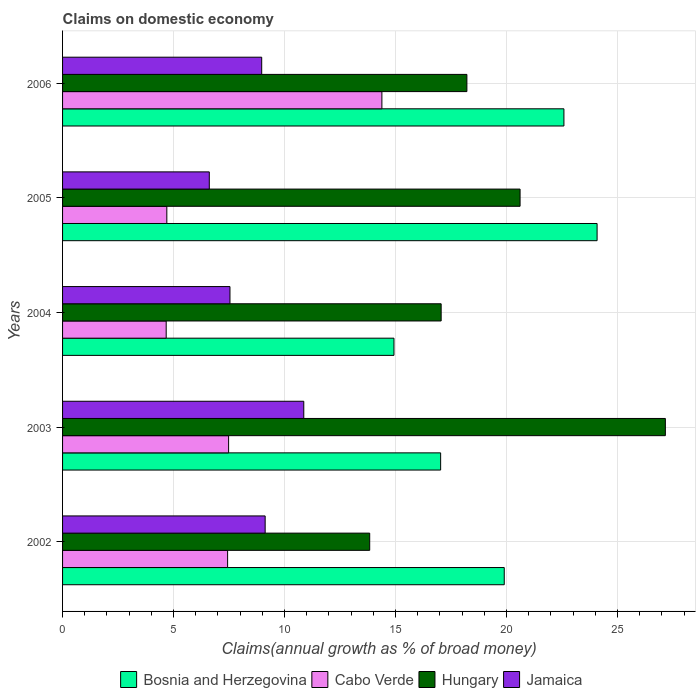How many different coloured bars are there?
Offer a very short reply. 4. How many groups of bars are there?
Offer a very short reply. 5. What is the percentage of broad money claimed on domestic economy in Hungary in 2005?
Provide a succinct answer. 20.61. Across all years, what is the maximum percentage of broad money claimed on domestic economy in Bosnia and Herzegovina?
Ensure brevity in your answer.  24.08. Across all years, what is the minimum percentage of broad money claimed on domestic economy in Cabo Verde?
Your answer should be compact. 4.67. What is the total percentage of broad money claimed on domestic economy in Bosnia and Herzegovina in the graph?
Provide a short and direct response. 98.54. What is the difference between the percentage of broad money claimed on domestic economy in Bosnia and Herzegovina in 2003 and that in 2005?
Keep it short and to the point. -7.05. What is the difference between the percentage of broad money claimed on domestic economy in Cabo Verde in 2004 and the percentage of broad money claimed on domestic economy in Hungary in 2005?
Give a very brief answer. -15.94. What is the average percentage of broad money claimed on domestic economy in Cabo Verde per year?
Your response must be concise. 7.73. In the year 2004, what is the difference between the percentage of broad money claimed on domestic economy in Jamaica and percentage of broad money claimed on domestic economy in Bosnia and Herzegovina?
Keep it short and to the point. -7.39. What is the ratio of the percentage of broad money claimed on domestic economy in Bosnia and Herzegovina in 2004 to that in 2006?
Offer a very short reply. 0.66. What is the difference between the highest and the second highest percentage of broad money claimed on domestic economy in Bosnia and Herzegovina?
Give a very brief answer. 1.49. What is the difference between the highest and the lowest percentage of broad money claimed on domestic economy in Jamaica?
Give a very brief answer. 4.26. In how many years, is the percentage of broad money claimed on domestic economy in Jamaica greater than the average percentage of broad money claimed on domestic economy in Jamaica taken over all years?
Offer a terse response. 3. Is the sum of the percentage of broad money claimed on domestic economy in Jamaica in 2004 and 2005 greater than the maximum percentage of broad money claimed on domestic economy in Bosnia and Herzegovina across all years?
Make the answer very short. No. Is it the case that in every year, the sum of the percentage of broad money claimed on domestic economy in Bosnia and Herzegovina and percentage of broad money claimed on domestic economy in Cabo Verde is greater than the sum of percentage of broad money claimed on domestic economy in Hungary and percentage of broad money claimed on domestic economy in Jamaica?
Ensure brevity in your answer.  No. What does the 2nd bar from the top in 2004 represents?
Your answer should be very brief. Hungary. What does the 3rd bar from the bottom in 2002 represents?
Provide a succinct answer. Hungary. Is it the case that in every year, the sum of the percentage of broad money claimed on domestic economy in Hungary and percentage of broad money claimed on domestic economy in Jamaica is greater than the percentage of broad money claimed on domestic economy in Bosnia and Herzegovina?
Offer a terse response. Yes. How many bars are there?
Your answer should be very brief. 20. Are all the bars in the graph horizontal?
Provide a succinct answer. Yes. What is the difference between two consecutive major ticks on the X-axis?
Provide a short and direct response. 5. Does the graph contain any zero values?
Make the answer very short. No. How are the legend labels stacked?
Offer a very short reply. Horizontal. What is the title of the graph?
Offer a terse response. Claims on domestic economy. What is the label or title of the X-axis?
Your answer should be compact. Claims(annual growth as % of broad money). What is the label or title of the Y-axis?
Make the answer very short. Years. What is the Claims(annual growth as % of broad money) of Bosnia and Herzegovina in 2002?
Offer a terse response. 19.9. What is the Claims(annual growth as % of broad money) of Cabo Verde in 2002?
Your answer should be very brief. 7.44. What is the Claims(annual growth as % of broad money) of Hungary in 2002?
Provide a succinct answer. 13.84. What is the Claims(annual growth as % of broad money) of Jamaica in 2002?
Provide a succinct answer. 9.13. What is the Claims(annual growth as % of broad money) in Bosnia and Herzegovina in 2003?
Keep it short and to the point. 17.04. What is the Claims(annual growth as % of broad money) in Cabo Verde in 2003?
Your answer should be compact. 7.48. What is the Claims(annual growth as % of broad money) of Hungary in 2003?
Provide a short and direct response. 27.16. What is the Claims(annual growth as % of broad money) in Jamaica in 2003?
Ensure brevity in your answer.  10.87. What is the Claims(annual growth as % of broad money) in Bosnia and Herzegovina in 2004?
Your answer should be very brief. 14.93. What is the Claims(annual growth as % of broad money) of Cabo Verde in 2004?
Your answer should be very brief. 4.67. What is the Claims(annual growth as % of broad money) of Hungary in 2004?
Ensure brevity in your answer.  17.06. What is the Claims(annual growth as % of broad money) of Jamaica in 2004?
Ensure brevity in your answer.  7.54. What is the Claims(annual growth as % of broad money) of Bosnia and Herzegovina in 2005?
Provide a short and direct response. 24.08. What is the Claims(annual growth as % of broad money) of Cabo Verde in 2005?
Your answer should be very brief. 4.7. What is the Claims(annual growth as % of broad money) of Hungary in 2005?
Provide a succinct answer. 20.61. What is the Claims(annual growth as % of broad money) in Jamaica in 2005?
Offer a very short reply. 6.61. What is the Claims(annual growth as % of broad money) in Bosnia and Herzegovina in 2006?
Provide a succinct answer. 22.59. What is the Claims(annual growth as % of broad money) in Cabo Verde in 2006?
Provide a succinct answer. 14.39. What is the Claims(annual growth as % of broad money) in Hungary in 2006?
Provide a short and direct response. 18.22. What is the Claims(annual growth as % of broad money) of Jamaica in 2006?
Provide a succinct answer. 8.97. Across all years, what is the maximum Claims(annual growth as % of broad money) of Bosnia and Herzegovina?
Your response must be concise. 24.08. Across all years, what is the maximum Claims(annual growth as % of broad money) of Cabo Verde?
Your answer should be compact. 14.39. Across all years, what is the maximum Claims(annual growth as % of broad money) in Hungary?
Offer a terse response. 27.16. Across all years, what is the maximum Claims(annual growth as % of broad money) in Jamaica?
Ensure brevity in your answer.  10.87. Across all years, what is the minimum Claims(annual growth as % of broad money) of Bosnia and Herzegovina?
Offer a very short reply. 14.93. Across all years, what is the minimum Claims(annual growth as % of broad money) in Cabo Verde?
Your answer should be compact. 4.67. Across all years, what is the minimum Claims(annual growth as % of broad money) in Hungary?
Make the answer very short. 13.84. Across all years, what is the minimum Claims(annual growth as % of broad money) in Jamaica?
Your answer should be compact. 6.61. What is the total Claims(annual growth as % of broad money) in Bosnia and Herzegovina in the graph?
Your response must be concise. 98.54. What is the total Claims(annual growth as % of broad money) of Cabo Verde in the graph?
Your answer should be very brief. 38.67. What is the total Claims(annual growth as % of broad money) in Hungary in the graph?
Your answer should be very brief. 96.89. What is the total Claims(annual growth as % of broad money) of Jamaica in the graph?
Offer a very short reply. 43.12. What is the difference between the Claims(annual growth as % of broad money) in Bosnia and Herzegovina in 2002 and that in 2003?
Your answer should be very brief. 2.87. What is the difference between the Claims(annual growth as % of broad money) of Cabo Verde in 2002 and that in 2003?
Provide a succinct answer. -0.05. What is the difference between the Claims(annual growth as % of broad money) in Hungary in 2002 and that in 2003?
Provide a succinct answer. -13.32. What is the difference between the Claims(annual growth as % of broad money) of Jamaica in 2002 and that in 2003?
Provide a succinct answer. -1.74. What is the difference between the Claims(annual growth as % of broad money) in Bosnia and Herzegovina in 2002 and that in 2004?
Provide a succinct answer. 4.97. What is the difference between the Claims(annual growth as % of broad money) in Cabo Verde in 2002 and that in 2004?
Provide a succinct answer. 2.77. What is the difference between the Claims(annual growth as % of broad money) in Hungary in 2002 and that in 2004?
Keep it short and to the point. -3.22. What is the difference between the Claims(annual growth as % of broad money) in Jamaica in 2002 and that in 2004?
Offer a very short reply. 1.59. What is the difference between the Claims(annual growth as % of broad money) in Bosnia and Herzegovina in 2002 and that in 2005?
Your response must be concise. -4.18. What is the difference between the Claims(annual growth as % of broad money) in Cabo Verde in 2002 and that in 2005?
Your response must be concise. 2.74. What is the difference between the Claims(annual growth as % of broad money) of Hungary in 2002 and that in 2005?
Keep it short and to the point. -6.78. What is the difference between the Claims(annual growth as % of broad money) of Jamaica in 2002 and that in 2005?
Ensure brevity in your answer.  2.52. What is the difference between the Claims(annual growth as % of broad money) in Bosnia and Herzegovina in 2002 and that in 2006?
Ensure brevity in your answer.  -2.69. What is the difference between the Claims(annual growth as % of broad money) in Cabo Verde in 2002 and that in 2006?
Give a very brief answer. -6.95. What is the difference between the Claims(annual growth as % of broad money) in Hungary in 2002 and that in 2006?
Your response must be concise. -4.38. What is the difference between the Claims(annual growth as % of broad money) in Jamaica in 2002 and that in 2006?
Keep it short and to the point. 0.16. What is the difference between the Claims(annual growth as % of broad money) in Bosnia and Herzegovina in 2003 and that in 2004?
Your response must be concise. 2.1. What is the difference between the Claims(annual growth as % of broad money) of Cabo Verde in 2003 and that in 2004?
Provide a short and direct response. 2.81. What is the difference between the Claims(annual growth as % of broad money) in Hungary in 2003 and that in 2004?
Make the answer very short. 10.1. What is the difference between the Claims(annual growth as % of broad money) in Jamaica in 2003 and that in 2004?
Make the answer very short. 3.33. What is the difference between the Claims(annual growth as % of broad money) in Bosnia and Herzegovina in 2003 and that in 2005?
Ensure brevity in your answer.  -7.05. What is the difference between the Claims(annual growth as % of broad money) in Cabo Verde in 2003 and that in 2005?
Provide a succinct answer. 2.78. What is the difference between the Claims(annual growth as % of broad money) of Hungary in 2003 and that in 2005?
Ensure brevity in your answer.  6.55. What is the difference between the Claims(annual growth as % of broad money) in Jamaica in 2003 and that in 2005?
Your answer should be very brief. 4.26. What is the difference between the Claims(annual growth as % of broad money) of Bosnia and Herzegovina in 2003 and that in 2006?
Keep it short and to the point. -5.55. What is the difference between the Claims(annual growth as % of broad money) of Cabo Verde in 2003 and that in 2006?
Ensure brevity in your answer.  -6.91. What is the difference between the Claims(annual growth as % of broad money) in Hungary in 2003 and that in 2006?
Your response must be concise. 8.94. What is the difference between the Claims(annual growth as % of broad money) of Jamaica in 2003 and that in 2006?
Make the answer very short. 1.9. What is the difference between the Claims(annual growth as % of broad money) of Bosnia and Herzegovina in 2004 and that in 2005?
Give a very brief answer. -9.15. What is the difference between the Claims(annual growth as % of broad money) of Cabo Verde in 2004 and that in 2005?
Give a very brief answer. -0.03. What is the difference between the Claims(annual growth as % of broad money) in Hungary in 2004 and that in 2005?
Offer a terse response. -3.56. What is the difference between the Claims(annual growth as % of broad money) of Jamaica in 2004 and that in 2005?
Your answer should be compact. 0.93. What is the difference between the Claims(annual growth as % of broad money) in Bosnia and Herzegovina in 2004 and that in 2006?
Provide a succinct answer. -7.66. What is the difference between the Claims(annual growth as % of broad money) of Cabo Verde in 2004 and that in 2006?
Provide a short and direct response. -9.72. What is the difference between the Claims(annual growth as % of broad money) in Hungary in 2004 and that in 2006?
Keep it short and to the point. -1.16. What is the difference between the Claims(annual growth as % of broad money) of Jamaica in 2004 and that in 2006?
Keep it short and to the point. -1.43. What is the difference between the Claims(annual growth as % of broad money) in Bosnia and Herzegovina in 2005 and that in 2006?
Offer a terse response. 1.49. What is the difference between the Claims(annual growth as % of broad money) of Cabo Verde in 2005 and that in 2006?
Ensure brevity in your answer.  -9.69. What is the difference between the Claims(annual growth as % of broad money) in Hungary in 2005 and that in 2006?
Provide a succinct answer. 2.4. What is the difference between the Claims(annual growth as % of broad money) in Jamaica in 2005 and that in 2006?
Offer a very short reply. -2.36. What is the difference between the Claims(annual growth as % of broad money) in Bosnia and Herzegovina in 2002 and the Claims(annual growth as % of broad money) in Cabo Verde in 2003?
Your response must be concise. 12.42. What is the difference between the Claims(annual growth as % of broad money) in Bosnia and Herzegovina in 2002 and the Claims(annual growth as % of broad money) in Hungary in 2003?
Provide a short and direct response. -7.26. What is the difference between the Claims(annual growth as % of broad money) of Bosnia and Herzegovina in 2002 and the Claims(annual growth as % of broad money) of Jamaica in 2003?
Offer a very short reply. 9.03. What is the difference between the Claims(annual growth as % of broad money) of Cabo Verde in 2002 and the Claims(annual growth as % of broad money) of Hungary in 2003?
Make the answer very short. -19.72. What is the difference between the Claims(annual growth as % of broad money) of Cabo Verde in 2002 and the Claims(annual growth as % of broad money) of Jamaica in 2003?
Provide a succinct answer. -3.43. What is the difference between the Claims(annual growth as % of broad money) of Hungary in 2002 and the Claims(annual growth as % of broad money) of Jamaica in 2003?
Give a very brief answer. 2.97. What is the difference between the Claims(annual growth as % of broad money) in Bosnia and Herzegovina in 2002 and the Claims(annual growth as % of broad money) in Cabo Verde in 2004?
Ensure brevity in your answer.  15.23. What is the difference between the Claims(annual growth as % of broad money) of Bosnia and Herzegovina in 2002 and the Claims(annual growth as % of broad money) of Hungary in 2004?
Your response must be concise. 2.84. What is the difference between the Claims(annual growth as % of broad money) of Bosnia and Herzegovina in 2002 and the Claims(annual growth as % of broad money) of Jamaica in 2004?
Your answer should be compact. 12.36. What is the difference between the Claims(annual growth as % of broad money) in Cabo Verde in 2002 and the Claims(annual growth as % of broad money) in Hungary in 2004?
Provide a succinct answer. -9.62. What is the difference between the Claims(annual growth as % of broad money) of Cabo Verde in 2002 and the Claims(annual growth as % of broad money) of Jamaica in 2004?
Your answer should be very brief. -0.11. What is the difference between the Claims(annual growth as % of broad money) of Hungary in 2002 and the Claims(annual growth as % of broad money) of Jamaica in 2004?
Keep it short and to the point. 6.3. What is the difference between the Claims(annual growth as % of broad money) of Bosnia and Herzegovina in 2002 and the Claims(annual growth as % of broad money) of Cabo Verde in 2005?
Make the answer very short. 15.2. What is the difference between the Claims(annual growth as % of broad money) of Bosnia and Herzegovina in 2002 and the Claims(annual growth as % of broad money) of Hungary in 2005?
Offer a very short reply. -0.71. What is the difference between the Claims(annual growth as % of broad money) of Bosnia and Herzegovina in 2002 and the Claims(annual growth as % of broad money) of Jamaica in 2005?
Provide a short and direct response. 13.29. What is the difference between the Claims(annual growth as % of broad money) of Cabo Verde in 2002 and the Claims(annual growth as % of broad money) of Hungary in 2005?
Give a very brief answer. -13.18. What is the difference between the Claims(annual growth as % of broad money) of Cabo Verde in 2002 and the Claims(annual growth as % of broad money) of Jamaica in 2005?
Ensure brevity in your answer.  0.82. What is the difference between the Claims(annual growth as % of broad money) of Hungary in 2002 and the Claims(annual growth as % of broad money) of Jamaica in 2005?
Offer a very short reply. 7.23. What is the difference between the Claims(annual growth as % of broad money) of Bosnia and Herzegovina in 2002 and the Claims(annual growth as % of broad money) of Cabo Verde in 2006?
Ensure brevity in your answer.  5.51. What is the difference between the Claims(annual growth as % of broad money) in Bosnia and Herzegovina in 2002 and the Claims(annual growth as % of broad money) in Hungary in 2006?
Your answer should be compact. 1.68. What is the difference between the Claims(annual growth as % of broad money) in Bosnia and Herzegovina in 2002 and the Claims(annual growth as % of broad money) in Jamaica in 2006?
Give a very brief answer. 10.93. What is the difference between the Claims(annual growth as % of broad money) in Cabo Verde in 2002 and the Claims(annual growth as % of broad money) in Hungary in 2006?
Keep it short and to the point. -10.78. What is the difference between the Claims(annual growth as % of broad money) of Cabo Verde in 2002 and the Claims(annual growth as % of broad money) of Jamaica in 2006?
Give a very brief answer. -1.54. What is the difference between the Claims(annual growth as % of broad money) of Hungary in 2002 and the Claims(annual growth as % of broad money) of Jamaica in 2006?
Offer a terse response. 4.87. What is the difference between the Claims(annual growth as % of broad money) of Bosnia and Herzegovina in 2003 and the Claims(annual growth as % of broad money) of Cabo Verde in 2004?
Keep it short and to the point. 12.37. What is the difference between the Claims(annual growth as % of broad money) of Bosnia and Herzegovina in 2003 and the Claims(annual growth as % of broad money) of Hungary in 2004?
Your answer should be very brief. -0.02. What is the difference between the Claims(annual growth as % of broad money) of Bosnia and Herzegovina in 2003 and the Claims(annual growth as % of broad money) of Jamaica in 2004?
Offer a terse response. 9.49. What is the difference between the Claims(annual growth as % of broad money) in Cabo Verde in 2003 and the Claims(annual growth as % of broad money) in Hungary in 2004?
Offer a very short reply. -9.58. What is the difference between the Claims(annual growth as % of broad money) of Cabo Verde in 2003 and the Claims(annual growth as % of broad money) of Jamaica in 2004?
Offer a very short reply. -0.06. What is the difference between the Claims(annual growth as % of broad money) of Hungary in 2003 and the Claims(annual growth as % of broad money) of Jamaica in 2004?
Keep it short and to the point. 19.62. What is the difference between the Claims(annual growth as % of broad money) of Bosnia and Herzegovina in 2003 and the Claims(annual growth as % of broad money) of Cabo Verde in 2005?
Provide a succinct answer. 12.34. What is the difference between the Claims(annual growth as % of broad money) in Bosnia and Herzegovina in 2003 and the Claims(annual growth as % of broad money) in Hungary in 2005?
Your response must be concise. -3.58. What is the difference between the Claims(annual growth as % of broad money) in Bosnia and Herzegovina in 2003 and the Claims(annual growth as % of broad money) in Jamaica in 2005?
Make the answer very short. 10.42. What is the difference between the Claims(annual growth as % of broad money) in Cabo Verde in 2003 and the Claims(annual growth as % of broad money) in Hungary in 2005?
Offer a very short reply. -13.13. What is the difference between the Claims(annual growth as % of broad money) in Cabo Verde in 2003 and the Claims(annual growth as % of broad money) in Jamaica in 2005?
Offer a very short reply. 0.87. What is the difference between the Claims(annual growth as % of broad money) in Hungary in 2003 and the Claims(annual growth as % of broad money) in Jamaica in 2005?
Keep it short and to the point. 20.55. What is the difference between the Claims(annual growth as % of broad money) in Bosnia and Herzegovina in 2003 and the Claims(annual growth as % of broad money) in Cabo Verde in 2006?
Provide a succinct answer. 2.65. What is the difference between the Claims(annual growth as % of broad money) of Bosnia and Herzegovina in 2003 and the Claims(annual growth as % of broad money) of Hungary in 2006?
Offer a terse response. -1.18. What is the difference between the Claims(annual growth as % of broad money) in Bosnia and Herzegovina in 2003 and the Claims(annual growth as % of broad money) in Jamaica in 2006?
Provide a short and direct response. 8.06. What is the difference between the Claims(annual growth as % of broad money) of Cabo Verde in 2003 and the Claims(annual growth as % of broad money) of Hungary in 2006?
Offer a very short reply. -10.74. What is the difference between the Claims(annual growth as % of broad money) of Cabo Verde in 2003 and the Claims(annual growth as % of broad money) of Jamaica in 2006?
Your answer should be compact. -1.49. What is the difference between the Claims(annual growth as % of broad money) in Hungary in 2003 and the Claims(annual growth as % of broad money) in Jamaica in 2006?
Your answer should be very brief. 18.19. What is the difference between the Claims(annual growth as % of broad money) in Bosnia and Herzegovina in 2004 and the Claims(annual growth as % of broad money) in Cabo Verde in 2005?
Provide a short and direct response. 10.23. What is the difference between the Claims(annual growth as % of broad money) in Bosnia and Herzegovina in 2004 and the Claims(annual growth as % of broad money) in Hungary in 2005?
Offer a terse response. -5.68. What is the difference between the Claims(annual growth as % of broad money) in Bosnia and Herzegovina in 2004 and the Claims(annual growth as % of broad money) in Jamaica in 2005?
Keep it short and to the point. 8.32. What is the difference between the Claims(annual growth as % of broad money) in Cabo Verde in 2004 and the Claims(annual growth as % of broad money) in Hungary in 2005?
Your answer should be compact. -15.94. What is the difference between the Claims(annual growth as % of broad money) of Cabo Verde in 2004 and the Claims(annual growth as % of broad money) of Jamaica in 2005?
Your response must be concise. -1.94. What is the difference between the Claims(annual growth as % of broad money) in Hungary in 2004 and the Claims(annual growth as % of broad money) in Jamaica in 2005?
Your answer should be very brief. 10.45. What is the difference between the Claims(annual growth as % of broad money) in Bosnia and Herzegovina in 2004 and the Claims(annual growth as % of broad money) in Cabo Verde in 2006?
Provide a succinct answer. 0.54. What is the difference between the Claims(annual growth as % of broad money) of Bosnia and Herzegovina in 2004 and the Claims(annual growth as % of broad money) of Hungary in 2006?
Make the answer very short. -3.29. What is the difference between the Claims(annual growth as % of broad money) in Bosnia and Herzegovina in 2004 and the Claims(annual growth as % of broad money) in Jamaica in 2006?
Give a very brief answer. 5.96. What is the difference between the Claims(annual growth as % of broad money) in Cabo Verde in 2004 and the Claims(annual growth as % of broad money) in Hungary in 2006?
Offer a terse response. -13.55. What is the difference between the Claims(annual growth as % of broad money) in Cabo Verde in 2004 and the Claims(annual growth as % of broad money) in Jamaica in 2006?
Your answer should be compact. -4.3. What is the difference between the Claims(annual growth as % of broad money) in Hungary in 2004 and the Claims(annual growth as % of broad money) in Jamaica in 2006?
Ensure brevity in your answer.  8.09. What is the difference between the Claims(annual growth as % of broad money) of Bosnia and Herzegovina in 2005 and the Claims(annual growth as % of broad money) of Cabo Verde in 2006?
Keep it short and to the point. 9.7. What is the difference between the Claims(annual growth as % of broad money) in Bosnia and Herzegovina in 2005 and the Claims(annual growth as % of broad money) in Hungary in 2006?
Keep it short and to the point. 5.87. What is the difference between the Claims(annual growth as % of broad money) of Bosnia and Herzegovina in 2005 and the Claims(annual growth as % of broad money) of Jamaica in 2006?
Make the answer very short. 15.11. What is the difference between the Claims(annual growth as % of broad money) in Cabo Verde in 2005 and the Claims(annual growth as % of broad money) in Hungary in 2006?
Provide a short and direct response. -13.52. What is the difference between the Claims(annual growth as % of broad money) of Cabo Verde in 2005 and the Claims(annual growth as % of broad money) of Jamaica in 2006?
Give a very brief answer. -4.28. What is the difference between the Claims(annual growth as % of broad money) of Hungary in 2005 and the Claims(annual growth as % of broad money) of Jamaica in 2006?
Make the answer very short. 11.64. What is the average Claims(annual growth as % of broad money) in Bosnia and Herzegovina per year?
Your answer should be very brief. 19.71. What is the average Claims(annual growth as % of broad money) of Cabo Verde per year?
Give a very brief answer. 7.73. What is the average Claims(annual growth as % of broad money) of Hungary per year?
Offer a very short reply. 19.38. What is the average Claims(annual growth as % of broad money) in Jamaica per year?
Your response must be concise. 8.62. In the year 2002, what is the difference between the Claims(annual growth as % of broad money) of Bosnia and Herzegovina and Claims(annual growth as % of broad money) of Cabo Verde?
Your answer should be compact. 12.46. In the year 2002, what is the difference between the Claims(annual growth as % of broad money) of Bosnia and Herzegovina and Claims(annual growth as % of broad money) of Hungary?
Offer a terse response. 6.06. In the year 2002, what is the difference between the Claims(annual growth as % of broad money) of Bosnia and Herzegovina and Claims(annual growth as % of broad money) of Jamaica?
Provide a succinct answer. 10.77. In the year 2002, what is the difference between the Claims(annual growth as % of broad money) of Cabo Verde and Claims(annual growth as % of broad money) of Hungary?
Make the answer very short. -6.4. In the year 2002, what is the difference between the Claims(annual growth as % of broad money) in Cabo Verde and Claims(annual growth as % of broad money) in Jamaica?
Provide a succinct answer. -1.69. In the year 2002, what is the difference between the Claims(annual growth as % of broad money) in Hungary and Claims(annual growth as % of broad money) in Jamaica?
Provide a short and direct response. 4.71. In the year 2003, what is the difference between the Claims(annual growth as % of broad money) in Bosnia and Herzegovina and Claims(annual growth as % of broad money) in Cabo Verde?
Your answer should be very brief. 9.55. In the year 2003, what is the difference between the Claims(annual growth as % of broad money) in Bosnia and Herzegovina and Claims(annual growth as % of broad money) in Hungary?
Provide a short and direct response. -10.12. In the year 2003, what is the difference between the Claims(annual growth as % of broad money) of Bosnia and Herzegovina and Claims(annual growth as % of broad money) of Jamaica?
Provide a succinct answer. 6.17. In the year 2003, what is the difference between the Claims(annual growth as % of broad money) in Cabo Verde and Claims(annual growth as % of broad money) in Hungary?
Your answer should be compact. -19.68. In the year 2003, what is the difference between the Claims(annual growth as % of broad money) in Cabo Verde and Claims(annual growth as % of broad money) in Jamaica?
Provide a short and direct response. -3.39. In the year 2003, what is the difference between the Claims(annual growth as % of broad money) in Hungary and Claims(annual growth as % of broad money) in Jamaica?
Offer a very short reply. 16.29. In the year 2004, what is the difference between the Claims(annual growth as % of broad money) of Bosnia and Herzegovina and Claims(annual growth as % of broad money) of Cabo Verde?
Keep it short and to the point. 10.26. In the year 2004, what is the difference between the Claims(annual growth as % of broad money) of Bosnia and Herzegovina and Claims(annual growth as % of broad money) of Hungary?
Offer a terse response. -2.13. In the year 2004, what is the difference between the Claims(annual growth as % of broad money) in Bosnia and Herzegovina and Claims(annual growth as % of broad money) in Jamaica?
Offer a very short reply. 7.39. In the year 2004, what is the difference between the Claims(annual growth as % of broad money) in Cabo Verde and Claims(annual growth as % of broad money) in Hungary?
Keep it short and to the point. -12.39. In the year 2004, what is the difference between the Claims(annual growth as % of broad money) of Cabo Verde and Claims(annual growth as % of broad money) of Jamaica?
Your response must be concise. -2.87. In the year 2004, what is the difference between the Claims(annual growth as % of broad money) in Hungary and Claims(annual growth as % of broad money) in Jamaica?
Ensure brevity in your answer.  9.52. In the year 2005, what is the difference between the Claims(annual growth as % of broad money) in Bosnia and Herzegovina and Claims(annual growth as % of broad money) in Cabo Verde?
Ensure brevity in your answer.  19.39. In the year 2005, what is the difference between the Claims(annual growth as % of broad money) in Bosnia and Herzegovina and Claims(annual growth as % of broad money) in Hungary?
Give a very brief answer. 3.47. In the year 2005, what is the difference between the Claims(annual growth as % of broad money) of Bosnia and Herzegovina and Claims(annual growth as % of broad money) of Jamaica?
Ensure brevity in your answer.  17.47. In the year 2005, what is the difference between the Claims(annual growth as % of broad money) of Cabo Verde and Claims(annual growth as % of broad money) of Hungary?
Ensure brevity in your answer.  -15.92. In the year 2005, what is the difference between the Claims(annual growth as % of broad money) of Cabo Verde and Claims(annual growth as % of broad money) of Jamaica?
Provide a succinct answer. -1.91. In the year 2005, what is the difference between the Claims(annual growth as % of broad money) in Hungary and Claims(annual growth as % of broad money) in Jamaica?
Offer a very short reply. 14. In the year 2006, what is the difference between the Claims(annual growth as % of broad money) of Bosnia and Herzegovina and Claims(annual growth as % of broad money) of Cabo Verde?
Offer a very short reply. 8.2. In the year 2006, what is the difference between the Claims(annual growth as % of broad money) in Bosnia and Herzegovina and Claims(annual growth as % of broad money) in Hungary?
Give a very brief answer. 4.37. In the year 2006, what is the difference between the Claims(annual growth as % of broad money) of Bosnia and Herzegovina and Claims(annual growth as % of broad money) of Jamaica?
Provide a succinct answer. 13.62. In the year 2006, what is the difference between the Claims(annual growth as % of broad money) of Cabo Verde and Claims(annual growth as % of broad money) of Hungary?
Your answer should be very brief. -3.83. In the year 2006, what is the difference between the Claims(annual growth as % of broad money) in Cabo Verde and Claims(annual growth as % of broad money) in Jamaica?
Give a very brief answer. 5.41. In the year 2006, what is the difference between the Claims(annual growth as % of broad money) of Hungary and Claims(annual growth as % of broad money) of Jamaica?
Your response must be concise. 9.24. What is the ratio of the Claims(annual growth as % of broad money) of Bosnia and Herzegovina in 2002 to that in 2003?
Your answer should be compact. 1.17. What is the ratio of the Claims(annual growth as % of broad money) of Cabo Verde in 2002 to that in 2003?
Ensure brevity in your answer.  0.99. What is the ratio of the Claims(annual growth as % of broad money) of Hungary in 2002 to that in 2003?
Give a very brief answer. 0.51. What is the ratio of the Claims(annual growth as % of broad money) in Jamaica in 2002 to that in 2003?
Offer a very short reply. 0.84. What is the ratio of the Claims(annual growth as % of broad money) in Bosnia and Herzegovina in 2002 to that in 2004?
Make the answer very short. 1.33. What is the ratio of the Claims(annual growth as % of broad money) of Cabo Verde in 2002 to that in 2004?
Your response must be concise. 1.59. What is the ratio of the Claims(annual growth as % of broad money) in Hungary in 2002 to that in 2004?
Your answer should be compact. 0.81. What is the ratio of the Claims(annual growth as % of broad money) of Jamaica in 2002 to that in 2004?
Your response must be concise. 1.21. What is the ratio of the Claims(annual growth as % of broad money) in Bosnia and Herzegovina in 2002 to that in 2005?
Keep it short and to the point. 0.83. What is the ratio of the Claims(annual growth as % of broad money) of Cabo Verde in 2002 to that in 2005?
Your response must be concise. 1.58. What is the ratio of the Claims(annual growth as % of broad money) of Hungary in 2002 to that in 2005?
Give a very brief answer. 0.67. What is the ratio of the Claims(annual growth as % of broad money) in Jamaica in 2002 to that in 2005?
Make the answer very short. 1.38. What is the ratio of the Claims(annual growth as % of broad money) in Bosnia and Herzegovina in 2002 to that in 2006?
Your response must be concise. 0.88. What is the ratio of the Claims(annual growth as % of broad money) of Cabo Verde in 2002 to that in 2006?
Offer a terse response. 0.52. What is the ratio of the Claims(annual growth as % of broad money) in Hungary in 2002 to that in 2006?
Your answer should be very brief. 0.76. What is the ratio of the Claims(annual growth as % of broad money) in Jamaica in 2002 to that in 2006?
Ensure brevity in your answer.  1.02. What is the ratio of the Claims(annual growth as % of broad money) in Bosnia and Herzegovina in 2003 to that in 2004?
Your answer should be compact. 1.14. What is the ratio of the Claims(annual growth as % of broad money) in Cabo Verde in 2003 to that in 2004?
Provide a short and direct response. 1.6. What is the ratio of the Claims(annual growth as % of broad money) in Hungary in 2003 to that in 2004?
Your response must be concise. 1.59. What is the ratio of the Claims(annual growth as % of broad money) of Jamaica in 2003 to that in 2004?
Your answer should be very brief. 1.44. What is the ratio of the Claims(annual growth as % of broad money) in Bosnia and Herzegovina in 2003 to that in 2005?
Offer a very short reply. 0.71. What is the ratio of the Claims(annual growth as % of broad money) of Cabo Verde in 2003 to that in 2005?
Your response must be concise. 1.59. What is the ratio of the Claims(annual growth as % of broad money) of Hungary in 2003 to that in 2005?
Ensure brevity in your answer.  1.32. What is the ratio of the Claims(annual growth as % of broad money) in Jamaica in 2003 to that in 2005?
Provide a succinct answer. 1.64. What is the ratio of the Claims(annual growth as % of broad money) of Bosnia and Herzegovina in 2003 to that in 2006?
Provide a succinct answer. 0.75. What is the ratio of the Claims(annual growth as % of broad money) of Cabo Verde in 2003 to that in 2006?
Your answer should be very brief. 0.52. What is the ratio of the Claims(annual growth as % of broad money) in Hungary in 2003 to that in 2006?
Your answer should be very brief. 1.49. What is the ratio of the Claims(annual growth as % of broad money) of Jamaica in 2003 to that in 2006?
Offer a terse response. 1.21. What is the ratio of the Claims(annual growth as % of broad money) in Bosnia and Herzegovina in 2004 to that in 2005?
Offer a terse response. 0.62. What is the ratio of the Claims(annual growth as % of broad money) of Cabo Verde in 2004 to that in 2005?
Ensure brevity in your answer.  0.99. What is the ratio of the Claims(annual growth as % of broad money) in Hungary in 2004 to that in 2005?
Your answer should be compact. 0.83. What is the ratio of the Claims(annual growth as % of broad money) in Jamaica in 2004 to that in 2005?
Ensure brevity in your answer.  1.14. What is the ratio of the Claims(annual growth as % of broad money) in Bosnia and Herzegovina in 2004 to that in 2006?
Make the answer very short. 0.66. What is the ratio of the Claims(annual growth as % of broad money) in Cabo Verde in 2004 to that in 2006?
Make the answer very short. 0.32. What is the ratio of the Claims(annual growth as % of broad money) of Hungary in 2004 to that in 2006?
Offer a very short reply. 0.94. What is the ratio of the Claims(annual growth as % of broad money) of Jamaica in 2004 to that in 2006?
Offer a very short reply. 0.84. What is the ratio of the Claims(annual growth as % of broad money) in Bosnia and Herzegovina in 2005 to that in 2006?
Your answer should be very brief. 1.07. What is the ratio of the Claims(annual growth as % of broad money) of Cabo Verde in 2005 to that in 2006?
Keep it short and to the point. 0.33. What is the ratio of the Claims(annual growth as % of broad money) of Hungary in 2005 to that in 2006?
Keep it short and to the point. 1.13. What is the ratio of the Claims(annual growth as % of broad money) in Jamaica in 2005 to that in 2006?
Provide a short and direct response. 0.74. What is the difference between the highest and the second highest Claims(annual growth as % of broad money) in Bosnia and Herzegovina?
Your answer should be very brief. 1.49. What is the difference between the highest and the second highest Claims(annual growth as % of broad money) in Cabo Verde?
Your answer should be compact. 6.91. What is the difference between the highest and the second highest Claims(annual growth as % of broad money) in Hungary?
Make the answer very short. 6.55. What is the difference between the highest and the second highest Claims(annual growth as % of broad money) in Jamaica?
Make the answer very short. 1.74. What is the difference between the highest and the lowest Claims(annual growth as % of broad money) in Bosnia and Herzegovina?
Your answer should be compact. 9.15. What is the difference between the highest and the lowest Claims(annual growth as % of broad money) in Cabo Verde?
Offer a very short reply. 9.72. What is the difference between the highest and the lowest Claims(annual growth as % of broad money) of Hungary?
Your answer should be compact. 13.32. What is the difference between the highest and the lowest Claims(annual growth as % of broad money) in Jamaica?
Provide a succinct answer. 4.26. 